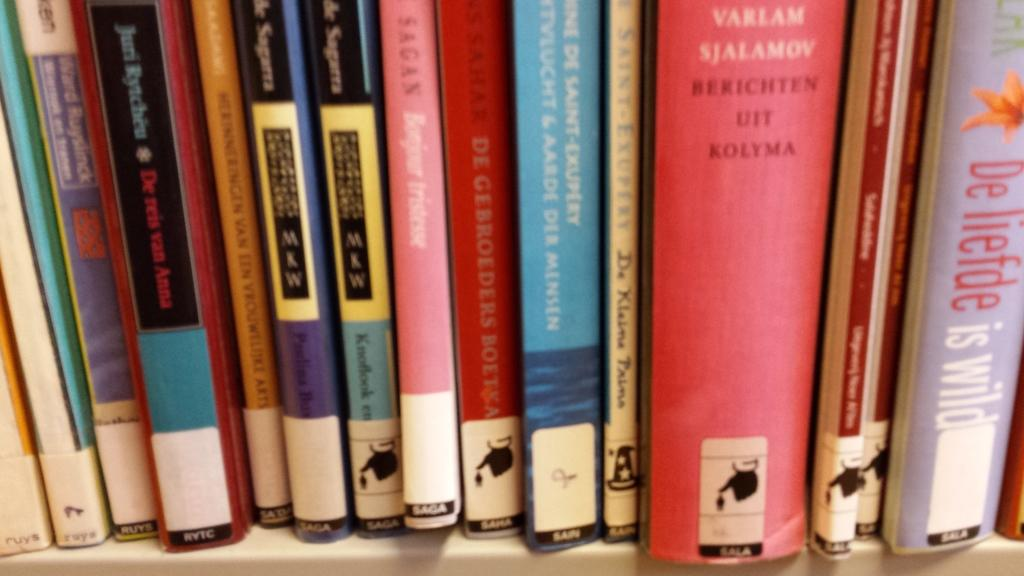<image>
Describe the image concisely. A row of German books including Berichten Uit Kolyma. 